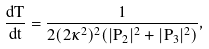<formula> <loc_0><loc_0><loc_500><loc_500>\frac { d T } { d t } = \frac { 1 } { 2 ( 2 \kappa ^ { 2 } ) ^ { 2 } ( | P _ { 2 } | ^ { 2 } + | P _ { 3 } | ^ { 2 } ) } ,</formula> 